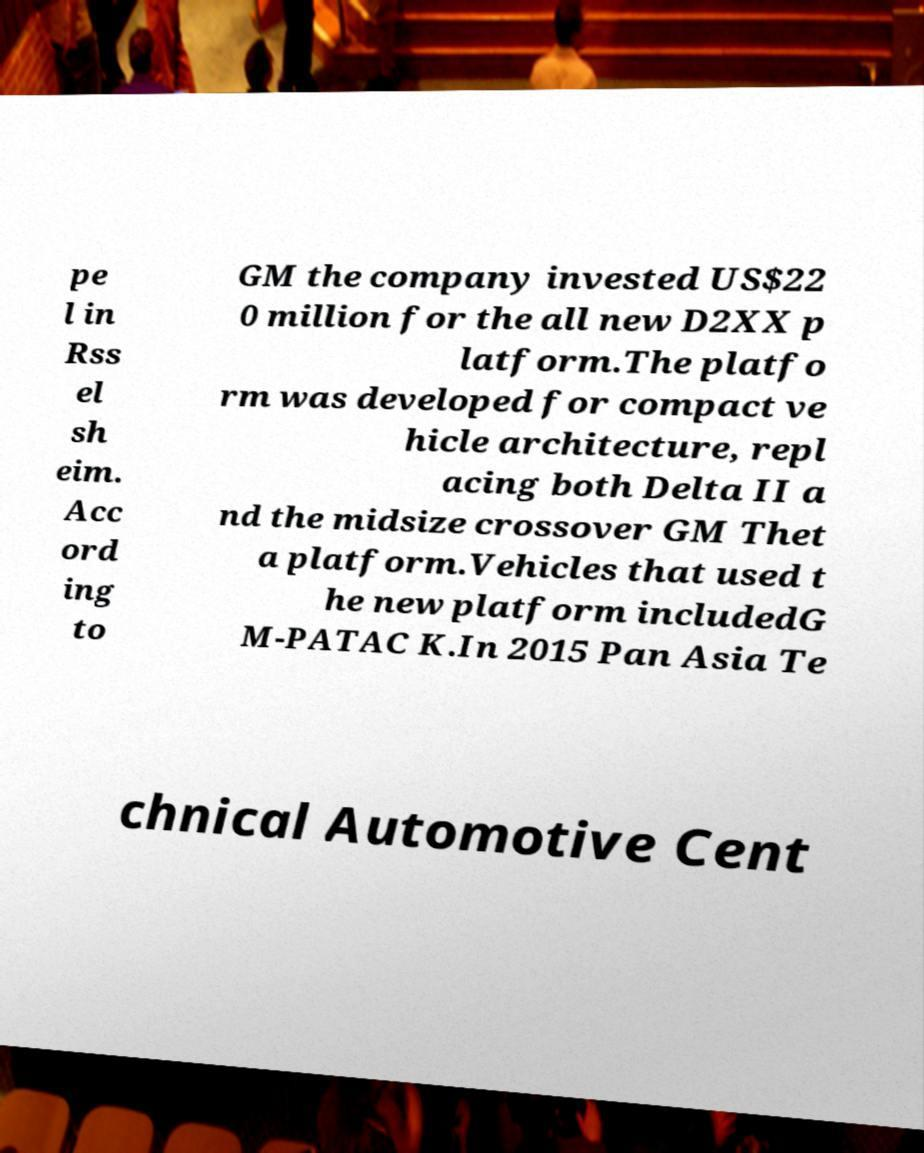Can you accurately transcribe the text from the provided image for me? pe l in Rss el sh eim. Acc ord ing to GM the company invested US$22 0 million for the all new D2XX p latform.The platfo rm was developed for compact ve hicle architecture, repl acing both Delta II a nd the midsize crossover GM Thet a platform.Vehicles that used t he new platform includedG M-PATAC K.In 2015 Pan Asia Te chnical Automotive Cent 